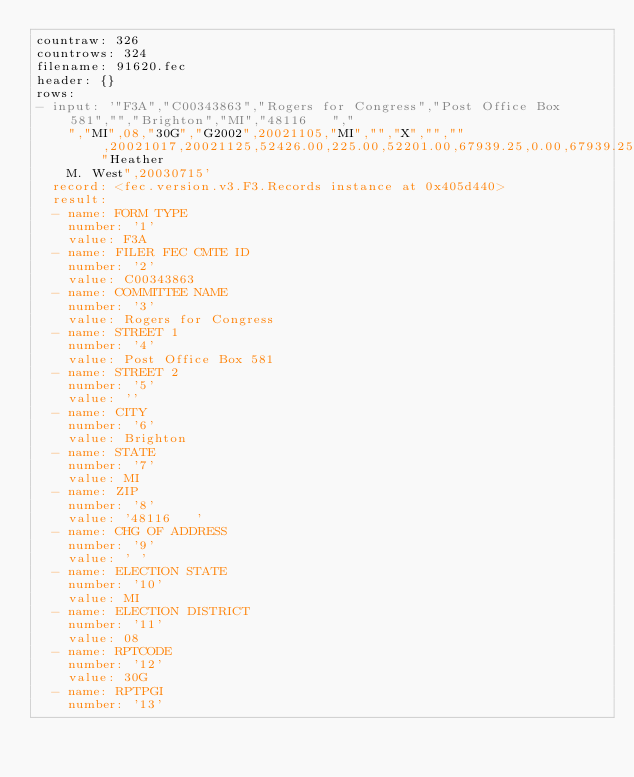Convert code to text. <code><loc_0><loc_0><loc_500><loc_500><_YAML_>countraw: 326
countrows: 324
filename: 91620.fec
header: {}
rows:
- input: '"F3A","C00343863","Rogers for Congress","Post Office Box 581","","Brighton","MI","48116   ","
    ","MI",08,"30G","G2002",20021105,"MI","","X","","",20021017,20021125,52426.00,225.00,52201.00,67939.25,0.00,67939.25,119127.25,0.00,0.00,24626.00,0.00,24626.00,0.00,27800.00,0.00,52426.00,0.00,0.00,0.00,0.00,0.00,0.00,52426.00,67939.25,0.00,0.00,0.00,0.00,225.00,0.00,0.00,225.00,0.00,68164.25,134865.50,52426.00,187291.50,68164.25,119127.25,1636065.42,7780.00,1628285.42,1486069.39,19586.23,1466483.16,,,982058.71,3561.38,650445.33,0.00,1636065.42,0.00,0.00,0.00,0.00,19586.23,20137.53,1675789.18,1486069.39,100000.00,0.00,0.00,0.00,2780.00,0.00,5000.00,7780.00,10000.00,1603849.39,"Heather
    M. West",20030715'
  record: <fec.version.v3.F3.Records instance at 0x405d440>
  result:
  - name: FORM TYPE
    number: '1'
    value: F3A
  - name: FILER FEC CMTE ID
    number: '2'
    value: C00343863
  - name: COMMITTEE NAME
    number: '3'
    value: Rogers for Congress
  - name: STREET 1
    number: '4'
    value: Post Office Box 581
  - name: STREET 2
    number: '5'
    value: ''
  - name: CITY
    number: '6'
    value: Brighton
  - name: STATE
    number: '7'
    value: MI
  - name: ZIP
    number: '8'
    value: '48116   '
  - name: CHG OF ADDRESS
    number: '9'
    value: ' '
  - name: ELECTION STATE
    number: '10'
    value: MI
  - name: ELECTION DISTRICT
    number: '11'
    value: 08
  - name: RPTCODE
    number: '12'
    value: 30G
  - name: RPTPGI
    number: '13'</code> 